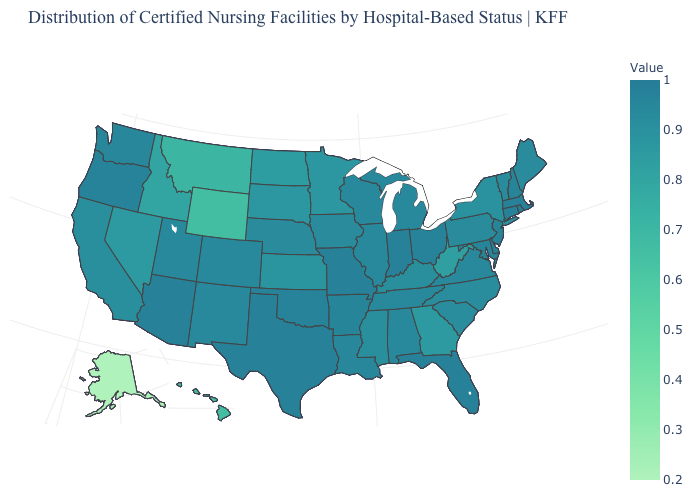Does Kansas have a lower value than Hawaii?
Quick response, please. No. Among the states that border Maine , which have the lowest value?
Short answer required. New Hampshire. 